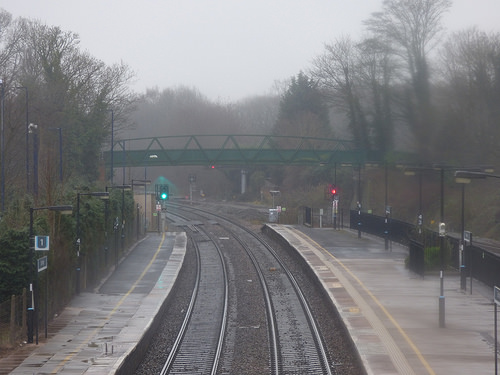<image>
Can you confirm if the red light is on the bridge? No. The red light is not positioned on the bridge. They may be near each other, but the red light is not supported by or resting on top of the bridge. 